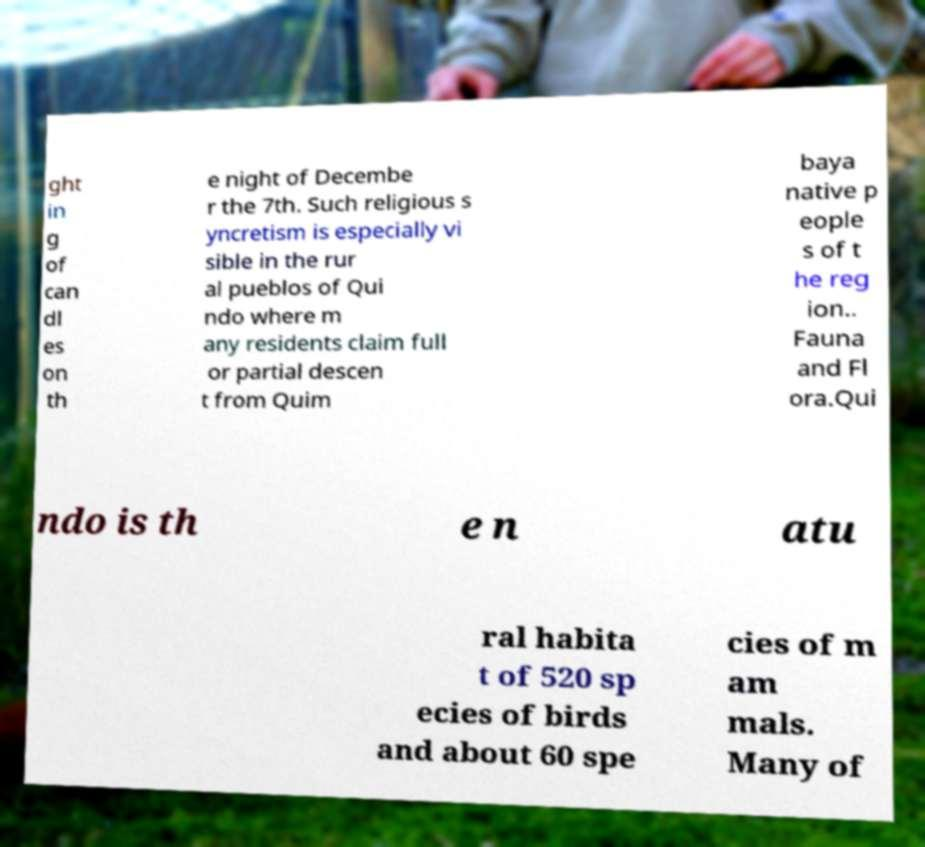Can you read and provide the text displayed in the image?This photo seems to have some interesting text. Can you extract and type it out for me? ght in g of can dl es on th e night of Decembe r the 7th. Such religious s yncretism is especially vi sible in the rur al pueblos of Qui ndo where m any residents claim full or partial descen t from Quim baya native p eople s of t he reg ion.. Fauna and Fl ora.Qui ndo is th e n atu ral habita t of 520 sp ecies of birds and about 60 spe cies of m am mals. Many of 